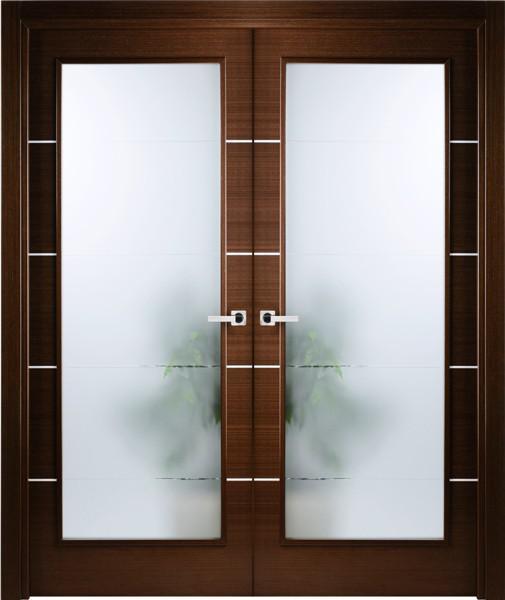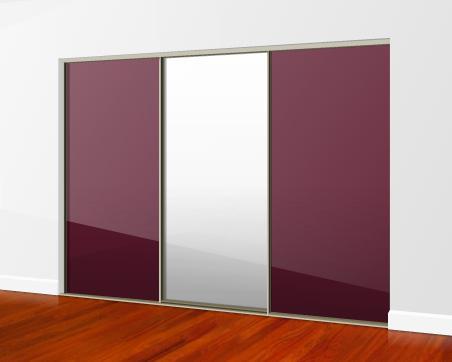The first image is the image on the left, the second image is the image on the right. Considering the images on both sides, is "One design shows a door with a white center section and colored sections flanking it." valid? Answer yes or no. Yes. The first image is the image on the left, the second image is the image on the right. Examine the images to the left and right. Is the description "there is a dark wooded floor in the image on the right" accurate? Answer yes or no. Yes. 